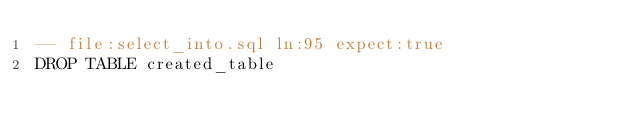<code> <loc_0><loc_0><loc_500><loc_500><_SQL_>-- file:select_into.sql ln:95 expect:true
DROP TABLE created_table
</code> 